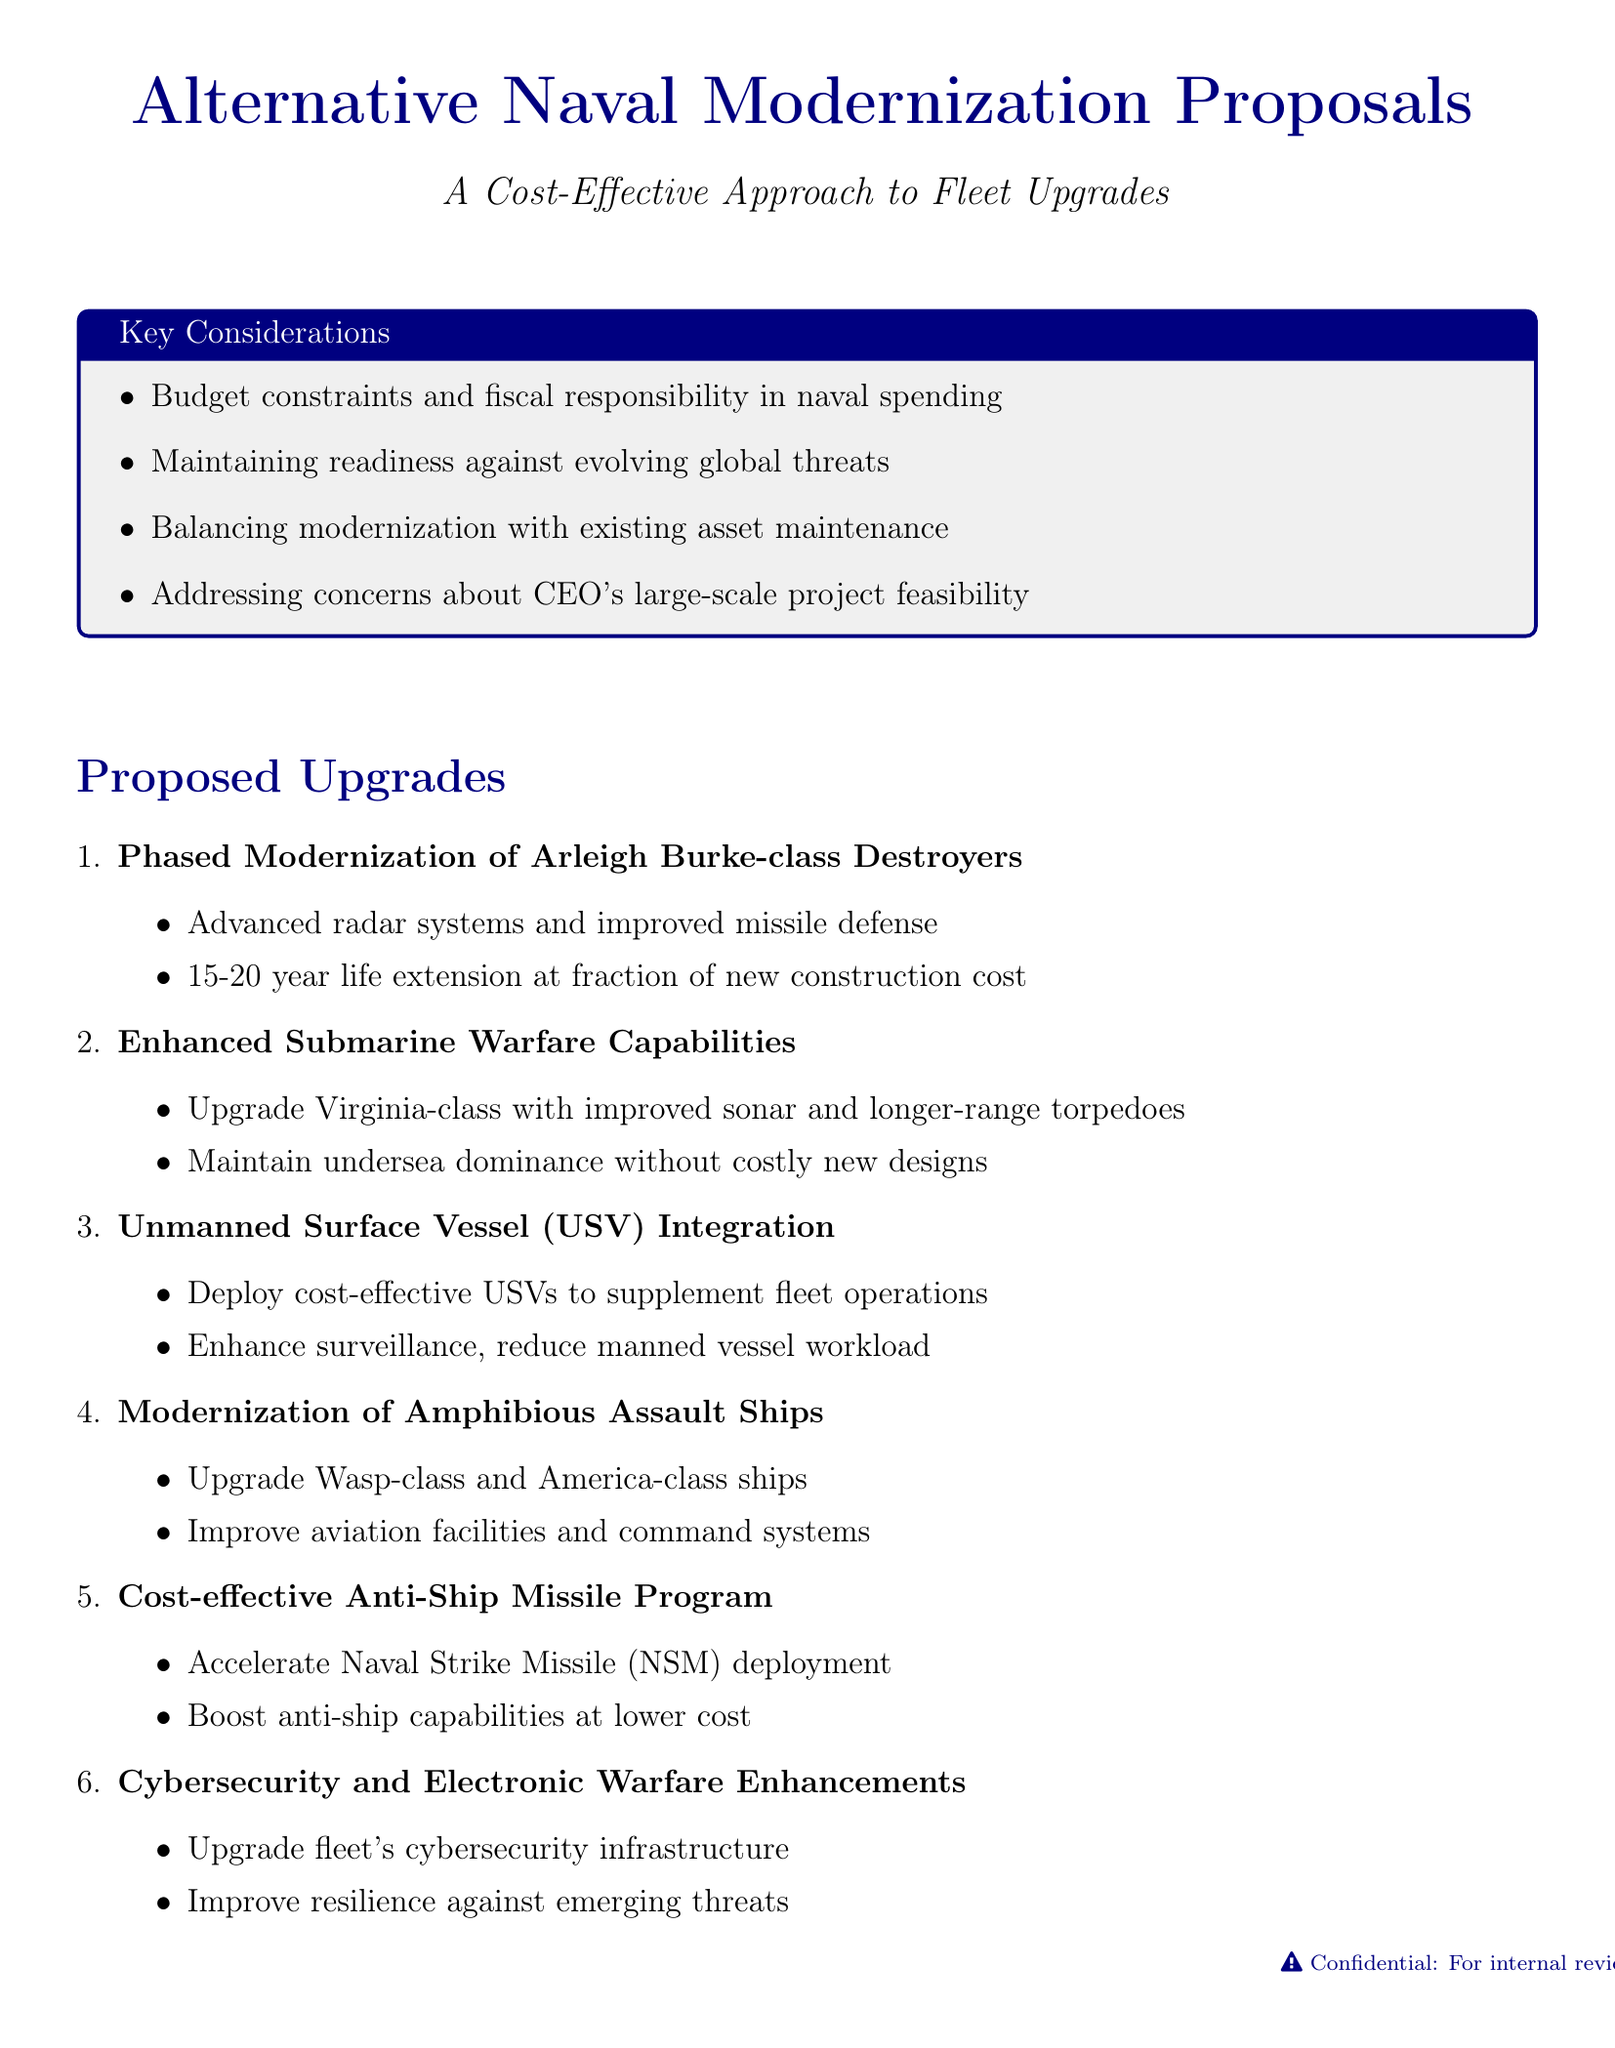What is the title of the first proposal? The title of the first proposal is listed under "Proposed Upgrades," which is "Phased Modernization of Arleigh Burke-class Destroyers."
Answer: Phased Modernization of Arleigh Burke-class Destroyers How many years can the Arleigh Burke-class destroyers' service life be extended? The document states that the service life can be extended by "15-20 years."
Answer: 15-20 years What type of missile is accelerated in the cost-effective program? The document specifies that the "Naval Strike Missile (NSM)" is being accelerated.
Answer: Naval Strike Missile (NSM) Which naval vessels are targeted for modernization under the amphibious assault category? The vessels targeted for modernization are indicated as the "Wasp-class and America-class amphibious assault ships."
Answer: Wasp-class and America-class Why are unmanned surface vessels (USVs) being developed? The development of USVs is aimed at "enhancing surveillance and reducing the workload on manned vessels."
Answer: Enhancing surveillance and reducing workload What is a key consideration regarding naval spending? A key consideration mentioned is "Budget constraints and the need for fiscal responsibility in naval spending."
Answer: Budget constraints and fiscal responsibility What is the focus of the cybersecurity enhancements proposal? The proposal aims to "improve resilience against emerging threats" through cybersecurity upgrades.
Answer: Improve resilience against emerging threats How many proposals are listed under proposed upgrades? The document lists a total of "six proposals" under proposed upgrades.
Answer: Six proposals 